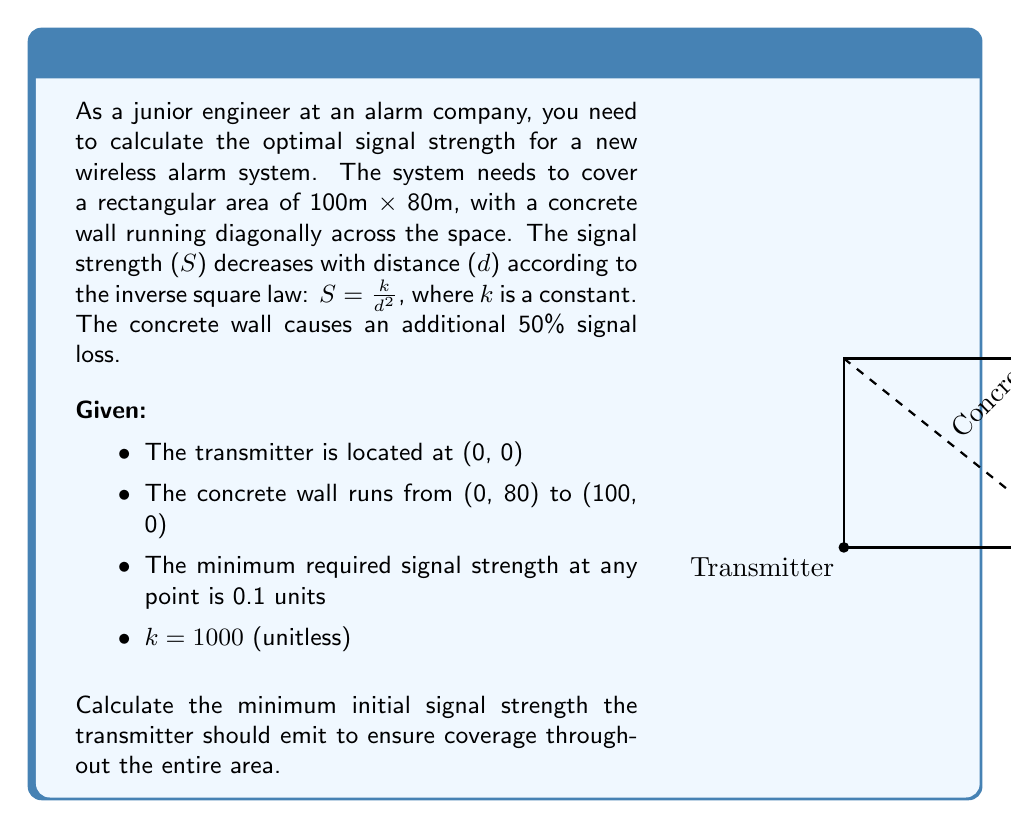Could you help me with this problem? Let's approach this step-by-step:

1) The worst-case scenario will be at the farthest corner from the transmitter, which is at (100, 80).

2) Calculate the distance to this point:
   $d = \sqrt{100^2 + 80^2} = \sqrt{16400} \approx 128.06$ m

3) The signal strength at this point without the wall would be:
   $S = \frac{k}{d^2} = \frac{1000}{128.06^2} \approx 0.0610$

4) However, the concrete wall causes an additional 50% signal loss. So the actual signal strength would be:
   $S_{actual} = 0.0610 \times 0.5 = 0.0305$

5) We need this to be at least 0.1 units. So we need to increase our initial signal strength by a factor of:
   $\frac{0.1}{0.0305} \approx 3.2787$

6) Therefore, the minimum initial signal strength (S_i) should be:
   $S_i = 1000 \times 3.2787 = 3278.7$

7) To verify:
   $S_{final} = \frac{3278.7}{128.06^2} \times 0.5 \approx 0.1$

This ensures that even at the farthest point, after passing through the wall, the signal strength meets the minimum requirement.
Answer: 3278.7 units 